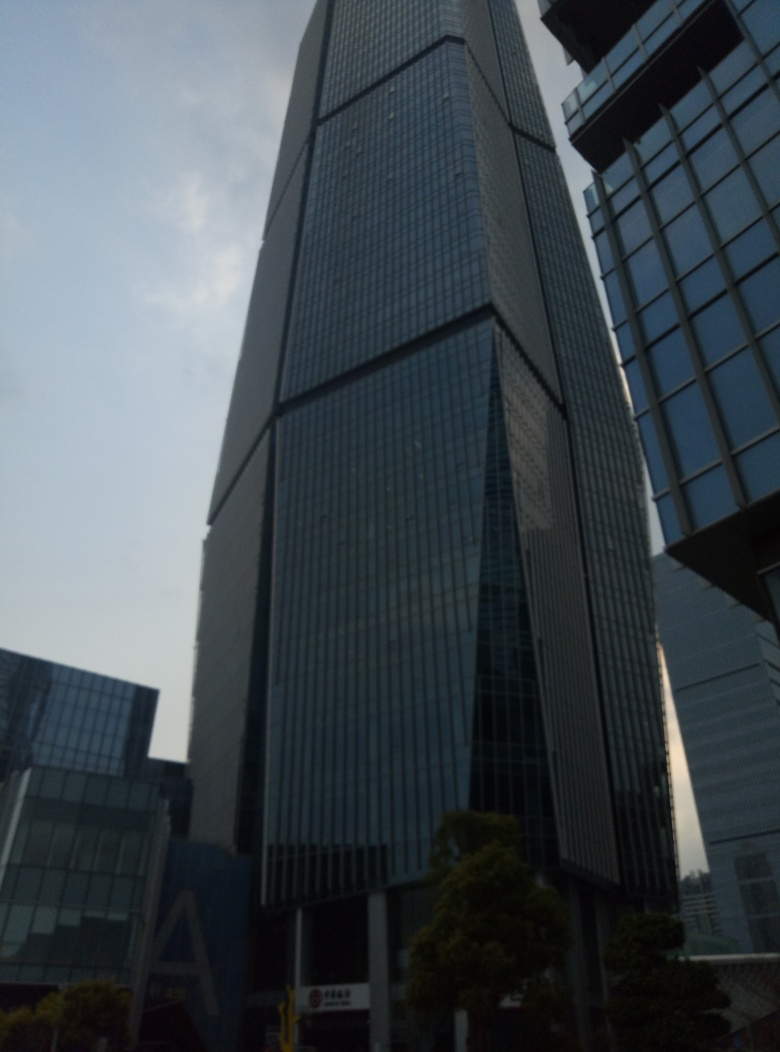The photo has been taken on a cloudy day. How would this building look on a sunny day? On a sunny day, the building's glass facade would interact differently with the light, reflecting the bright blue sky and possibly some sun glare, adding vibrancy to its appearance. The contrasts would be more pronounced, with the building casting sharp shadows on the ground or on adjacent structures. The mood conveyed by the image would shift from the current subdued tones to a more dynamic and lively scene, showcasing the building's design details more vividly. 